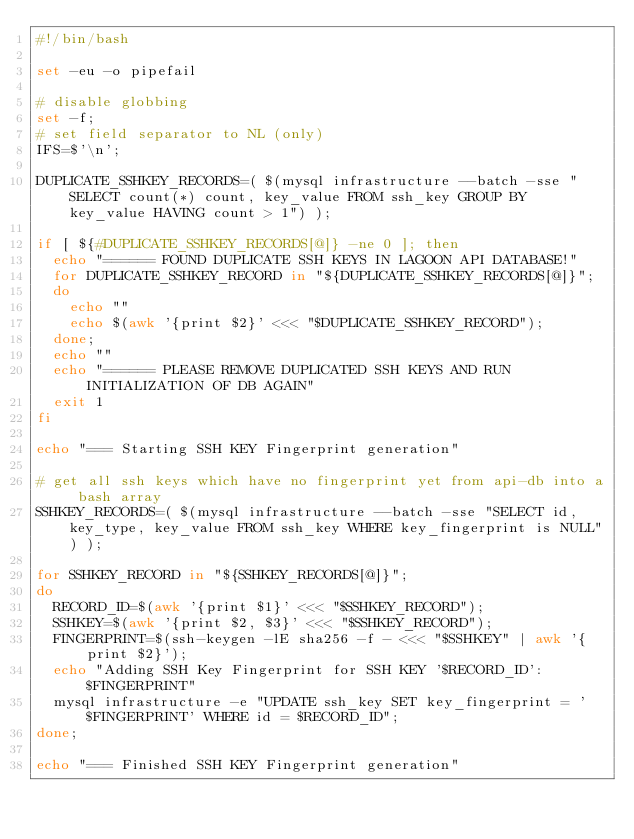<code> <loc_0><loc_0><loc_500><loc_500><_Bash_>#!/bin/bash

set -eu -o pipefail

# disable globbing
set -f;
# set field separator to NL (only)
IFS=$'\n';

DUPLICATE_SSHKEY_RECORDS=( $(mysql infrastructure --batch -sse "SELECT count(*) count, key_value FROM ssh_key GROUP BY key_value HAVING count > 1") );

if [ ${#DUPLICATE_SSHKEY_RECORDS[@]} -ne 0 ]; then
  echo "====== FOUND DUPLICATE SSH KEYS IN LAGOON API DATABASE!"
  for DUPLICATE_SSHKEY_RECORD in "${DUPLICATE_SSHKEY_RECORDS[@]}";
  do
    echo ""
    echo $(awk '{print $2}' <<< "$DUPLICATE_SSHKEY_RECORD");
  done;
  echo ""
  echo "====== PLEASE REMOVE DUPLICATED SSH KEYS AND RUN INITIALIZATION OF DB AGAIN"
  exit 1
fi

echo "=== Starting SSH KEY Fingerprint generation"

# get all ssh keys which have no fingerprint yet from api-db into a bash array
SSHKEY_RECORDS=( $(mysql infrastructure --batch -sse "SELECT id, key_type, key_value FROM ssh_key WHERE key_fingerprint is NULL") );

for SSHKEY_RECORD in "${SSHKEY_RECORDS[@]}";
do
  RECORD_ID=$(awk '{print $1}' <<< "$SSHKEY_RECORD");
  SSHKEY=$(awk '{print $2, $3}' <<< "$SSHKEY_RECORD");
  FINGERPRINT=$(ssh-keygen -lE sha256 -f - <<< "$SSHKEY" | awk '{print $2}');
  echo "Adding SSH Key Fingerprint for SSH KEY '$RECORD_ID': $FINGERPRINT"
  mysql infrastructure -e "UPDATE ssh_key SET key_fingerprint = '$FINGERPRINT' WHERE id = $RECORD_ID";
done;

echo "=== Finished SSH KEY Fingerprint generation"
</code> 